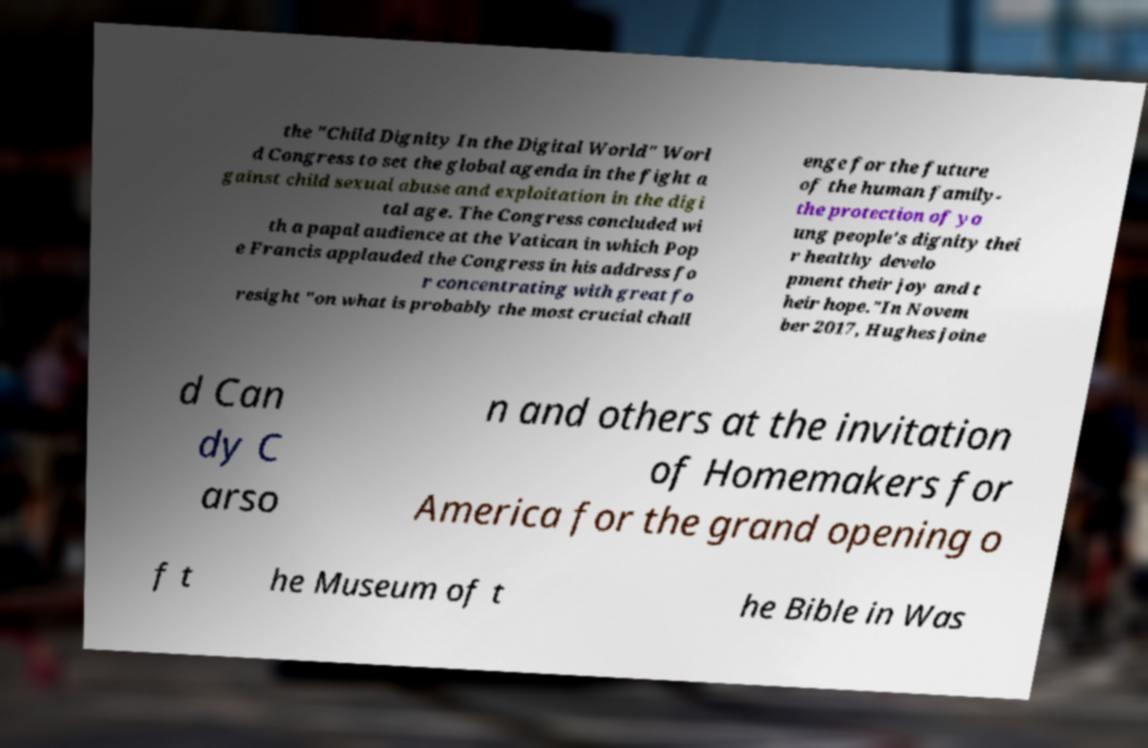For documentation purposes, I need the text within this image transcribed. Could you provide that? the "Child Dignity In the Digital World" Worl d Congress to set the global agenda in the fight a gainst child sexual abuse and exploitation in the digi tal age. The Congress concluded wi th a papal audience at the Vatican in which Pop e Francis applauded the Congress in his address fo r concentrating with great fo resight "on what is probably the most crucial chall enge for the future of the human family- the protection of yo ung people's dignity thei r healthy develo pment their joy and t heir hope."In Novem ber 2017, Hughes joine d Can dy C arso n and others at the invitation of Homemakers for America for the grand opening o f t he Museum of t he Bible in Was 